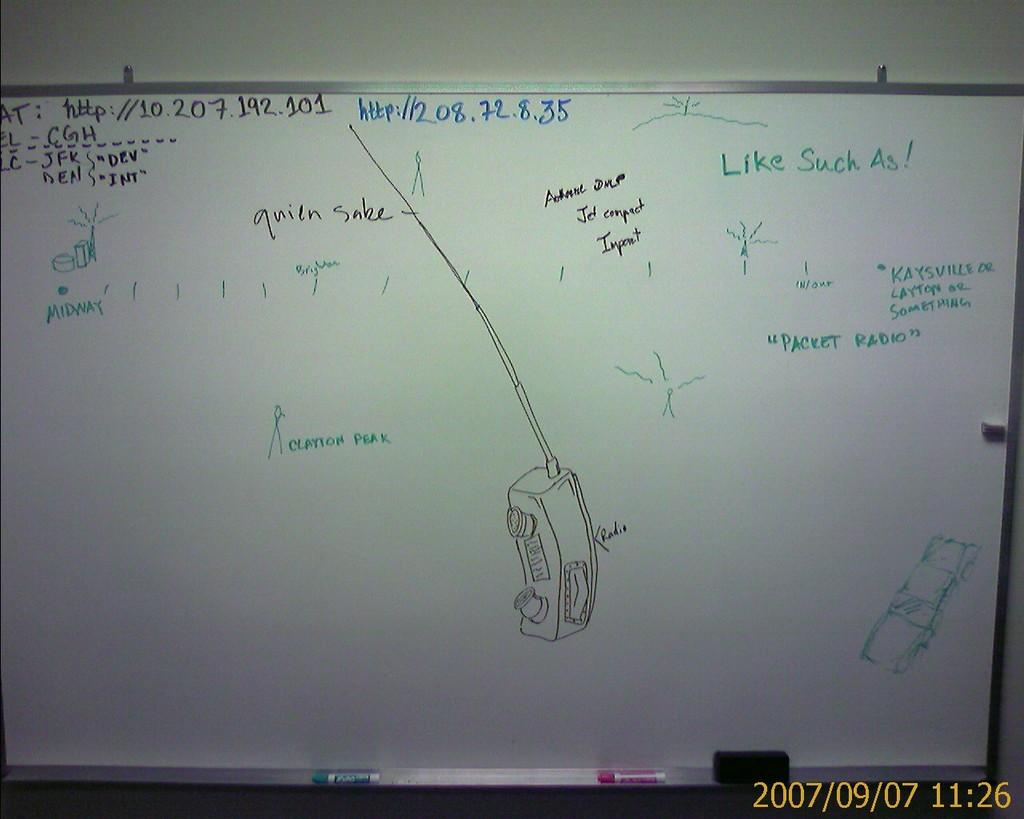Provide a one-sentence caption for the provided image. A whiteboard with sketches and annotations such as Clayton Peak. 